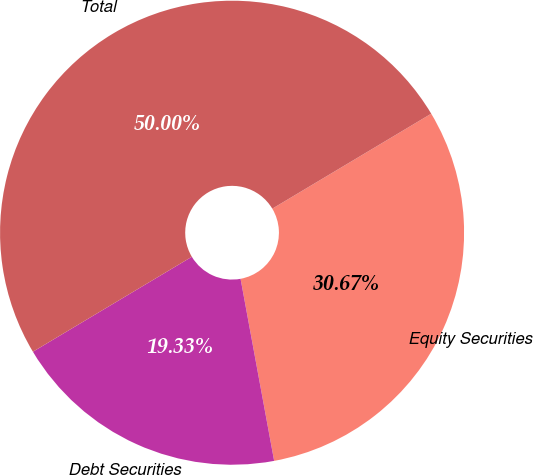Convert chart. <chart><loc_0><loc_0><loc_500><loc_500><pie_chart><fcel>Equity Securities<fcel>Debt Securities<fcel>Total<nl><fcel>30.67%<fcel>19.33%<fcel>50.0%<nl></chart> 